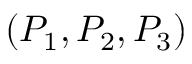Convert formula to latex. <formula><loc_0><loc_0><loc_500><loc_500>( P _ { 1 } , P _ { 2 } , P _ { 3 } )</formula> 